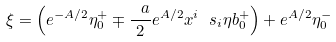<formula> <loc_0><loc_0><loc_500><loc_500>\xi = \left ( e ^ { - A / 2 } \eta ^ { + } _ { 0 } \mp \frac { \ a } { 2 } e ^ { A / 2 } x ^ { i } \ s _ { i } \eta b ^ { + } _ { 0 } \right ) + e ^ { A / 2 } \eta ^ { - } _ { 0 }</formula> 